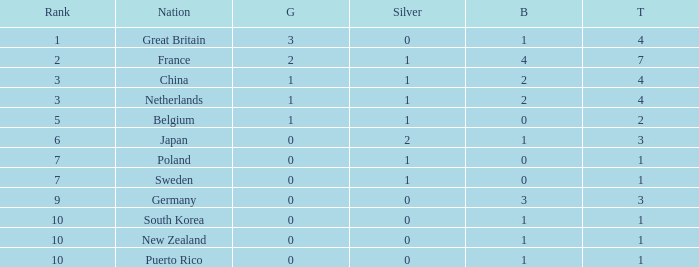What is the rank with 0 bronze? None. 